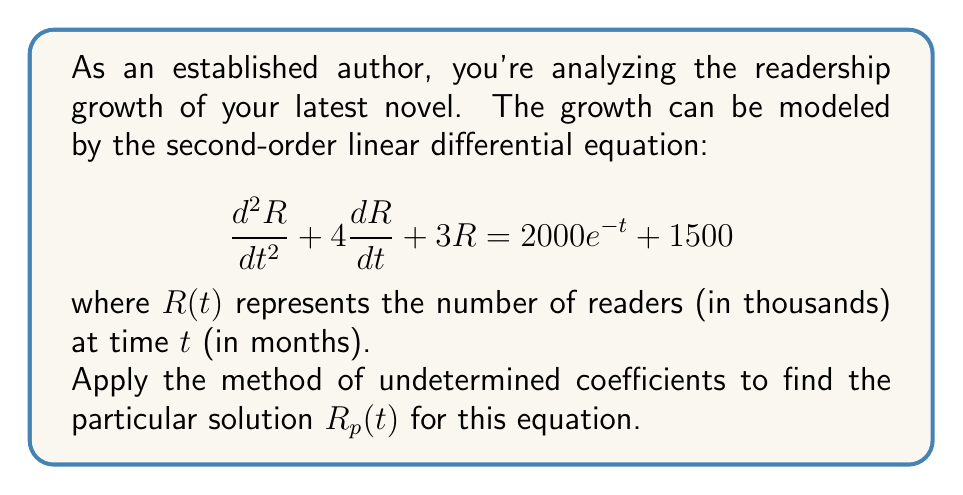Can you answer this question? Let's solve this step-by-step using the method of undetermined coefficients:

1) The right-hand side of the equation has two terms: $2000e^{-t}$ and 1500. We need to find a particular solution for each.

2) For $2000e^{-t}$:
   Let $R_{p1}(t) = Ae^{-t}$, where $A$ is a constant to be determined.
   $R_{p1}'(t) = -Ae^{-t}$
   $R_{p1}''(t) = Ae^{-t}$

   Substituting into the original equation:
   $$(Ae^{-t}) + 4(-Ae^{-t}) + 3(Ae^{-t}) = 2000e^{-t}$$
   $$(A - 4A + 3A)e^{-t} = 2000e^{-t}$$
   $$0 \cdot A = 2000$$
   
   This leads to a contradiction, so we need to modify our guess:
   Let $R_{p1}(t) = Ate^{-t}$
   $R_{p1}'(t) = Ae^{-t} - Ate^{-t}$
   $R_{p1}''(t) = Ae^{-t} - Ae^{-t} + Ate^{-t} = -Ae^{-t} + Ate^{-t}$

   Substituting into the original equation:
   $$(-Ae^{-t} + Ate^{-t}) + 4(Ae^{-t} - Ate^{-t}) + 3(Ate^{-t}) = 2000e^{-t}$$
   $$(-A + At + 4A - 4At + 3At)e^{-t} = 2000e^{-t}$$
   $$(3A)e^{-t} = 2000e^{-t}$$
   $$A = \frac{2000}{3}$$

3) For 1500:
   Let $R_{p2}(t) = B$, where $B$ is a constant to be determined.
   $R_{p2}'(t) = 0$
   $R_{p2}''(t) = 0$

   Substituting into the original equation:
   $$0 + 0 + 3B = 1500$$
   $$B = 500$$

4) The complete particular solution is the sum of $R_{p1}(t)$ and $R_{p2}(t)$:

   $$R_p(t) = \frac{2000}{3}te^{-t} + 500$$
Answer: $R_p(t) = \frac{2000}{3}te^{-t} + 500$ 